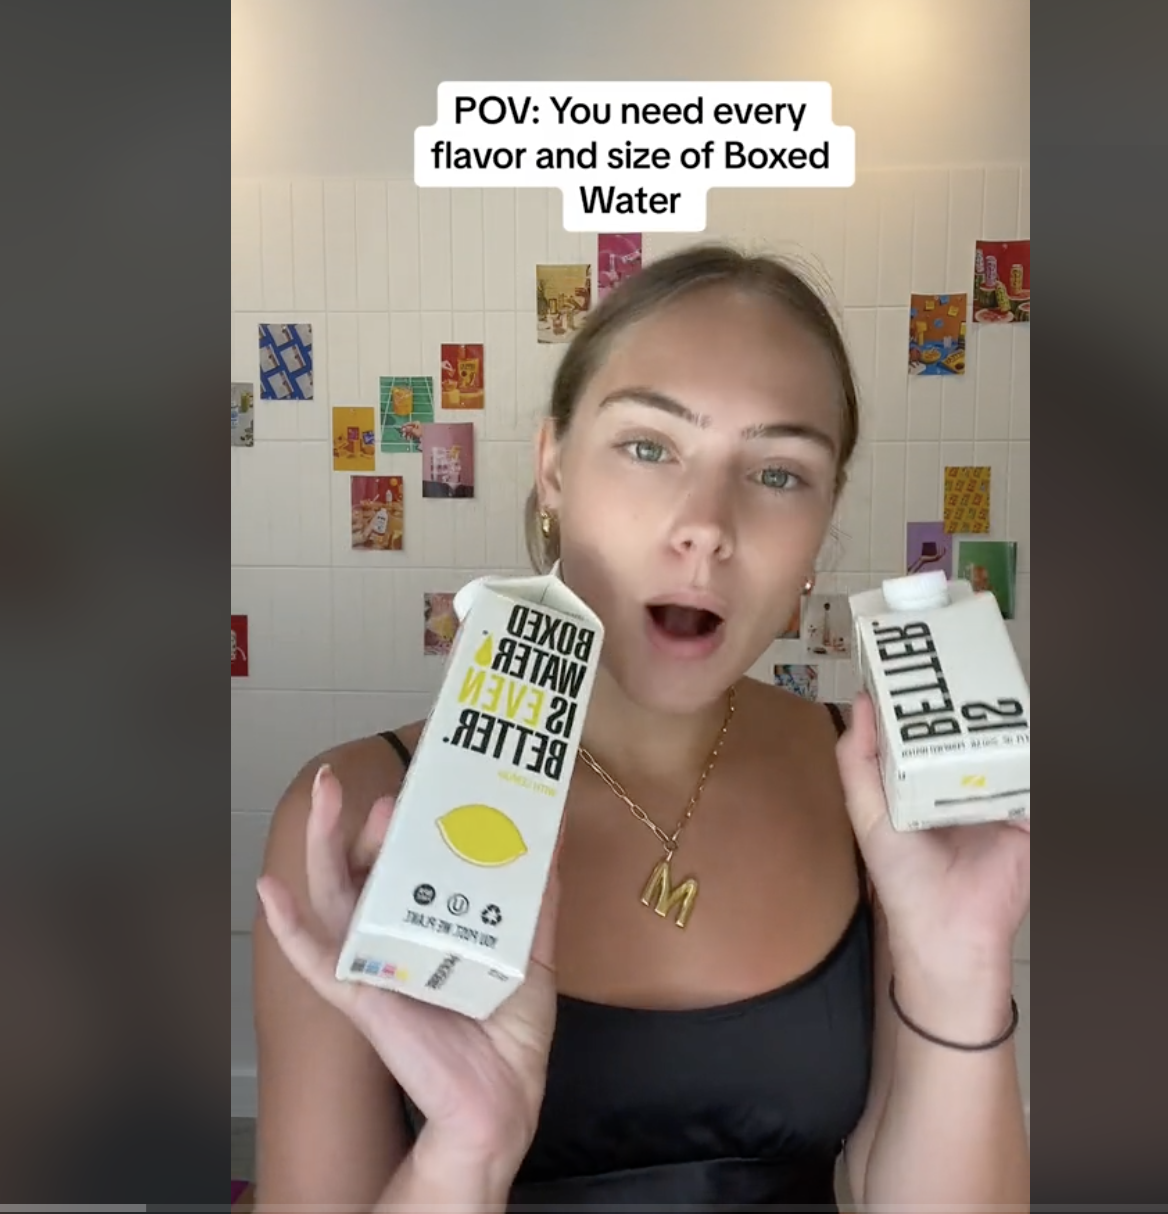Locate products This image appears to be a funny or sarcastic commentary on collecting various flavors and sizes of boxed water products. The image shows a young woman looking surprised and holding up two cartons or boxes of water with different brand names printed on them. Behind her, there are multiple small cardboard displays or boxes adhered to the tiled wall, which seem to represent different varieties or flavors of boxed water products. The text overlay suggests someone's humorous "point of view" that one needs to acquire every possible flavor and size variation of these boxed water products, though collecting so many varieties of basic water packaging seems unnecessary or excessive. 